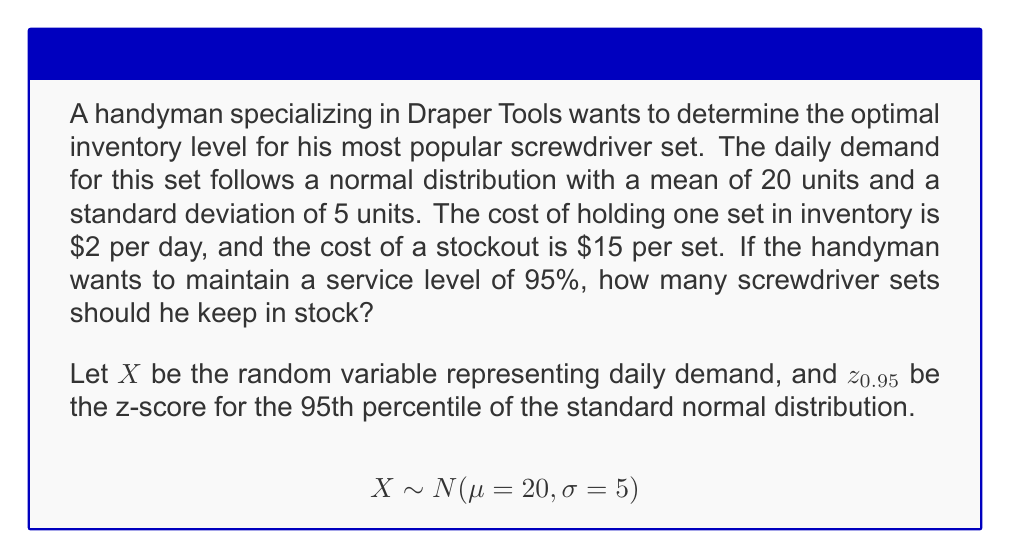Can you solve this math problem? To determine the optimal inventory level, we need to find the safety stock and add it to the mean demand. Here's the step-by-step process:

1. Find the z-score for the 95th percentile:
   $z_{0.95} = 1.645$ (from standard normal distribution table)

2. Calculate the safety stock:
   Safety Stock = $z_{0.95} \cdot \sigma = 1.645 \cdot 5 = 8.225$

3. Determine the optimal inventory level:
   Optimal Inventory = $\mu + \text{Safety Stock} = 20 + 8.225 = 28.225$

4. Since we can't stock fractional sets, we round up to the nearest whole number:
   Optimal Inventory = 29 sets

This inventory level ensures that the probability of meeting demand is at least 95%, balancing the costs of holding inventory and potential stockouts.

Note: We could have used the newsvendor formula to optimize based on costs, but the question specifies a desired service level, so we use the simpler method above.
Answer: 29 screwdriver sets 